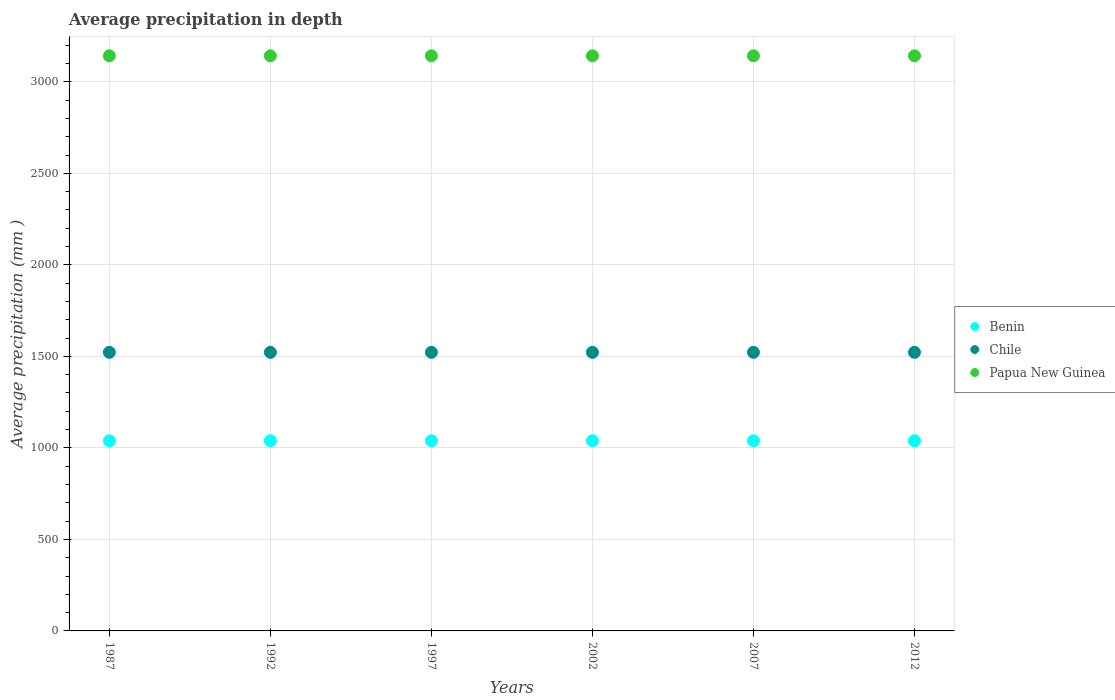What is the average precipitation in Papua New Guinea in 2002?
Give a very brief answer. 3142. Across all years, what is the maximum average precipitation in Benin?
Give a very brief answer. 1039. Across all years, what is the minimum average precipitation in Benin?
Ensure brevity in your answer.  1039. What is the total average precipitation in Chile in the graph?
Give a very brief answer. 9132. What is the difference between the average precipitation in Benin in 2002 and the average precipitation in Chile in 2007?
Your answer should be very brief. -483. What is the average average precipitation in Chile per year?
Your answer should be compact. 1522. In the year 1987, what is the difference between the average precipitation in Papua New Guinea and average precipitation in Benin?
Offer a terse response. 2103. Is the sum of the average precipitation in Papua New Guinea in 1992 and 2002 greater than the maximum average precipitation in Benin across all years?
Your response must be concise. Yes. Is it the case that in every year, the sum of the average precipitation in Benin and average precipitation in Chile  is greater than the average precipitation in Papua New Guinea?
Ensure brevity in your answer.  No. Does the average precipitation in Chile monotonically increase over the years?
Keep it short and to the point. No. Is the average precipitation in Papua New Guinea strictly greater than the average precipitation in Benin over the years?
Provide a succinct answer. Yes. How many dotlines are there?
Your response must be concise. 3. Does the graph contain grids?
Keep it short and to the point. Yes. How many legend labels are there?
Provide a short and direct response. 3. How are the legend labels stacked?
Provide a short and direct response. Vertical. What is the title of the graph?
Give a very brief answer. Average precipitation in depth. What is the label or title of the Y-axis?
Your response must be concise. Average precipitation (mm ). What is the Average precipitation (mm ) in Benin in 1987?
Offer a terse response. 1039. What is the Average precipitation (mm ) in Chile in 1987?
Provide a succinct answer. 1522. What is the Average precipitation (mm ) in Papua New Guinea in 1987?
Your response must be concise. 3142. What is the Average precipitation (mm ) of Benin in 1992?
Offer a terse response. 1039. What is the Average precipitation (mm ) in Chile in 1992?
Ensure brevity in your answer.  1522. What is the Average precipitation (mm ) in Papua New Guinea in 1992?
Offer a terse response. 3142. What is the Average precipitation (mm ) of Benin in 1997?
Ensure brevity in your answer.  1039. What is the Average precipitation (mm ) in Chile in 1997?
Make the answer very short. 1522. What is the Average precipitation (mm ) in Papua New Guinea in 1997?
Provide a succinct answer. 3142. What is the Average precipitation (mm ) in Benin in 2002?
Make the answer very short. 1039. What is the Average precipitation (mm ) of Chile in 2002?
Give a very brief answer. 1522. What is the Average precipitation (mm ) in Papua New Guinea in 2002?
Give a very brief answer. 3142. What is the Average precipitation (mm ) of Benin in 2007?
Your response must be concise. 1039. What is the Average precipitation (mm ) in Chile in 2007?
Provide a succinct answer. 1522. What is the Average precipitation (mm ) in Papua New Guinea in 2007?
Ensure brevity in your answer.  3142. What is the Average precipitation (mm ) in Benin in 2012?
Your answer should be very brief. 1039. What is the Average precipitation (mm ) of Chile in 2012?
Offer a terse response. 1522. What is the Average precipitation (mm ) of Papua New Guinea in 2012?
Provide a short and direct response. 3142. Across all years, what is the maximum Average precipitation (mm ) of Benin?
Ensure brevity in your answer.  1039. Across all years, what is the maximum Average precipitation (mm ) of Chile?
Ensure brevity in your answer.  1522. Across all years, what is the maximum Average precipitation (mm ) of Papua New Guinea?
Your answer should be very brief. 3142. Across all years, what is the minimum Average precipitation (mm ) in Benin?
Keep it short and to the point. 1039. Across all years, what is the minimum Average precipitation (mm ) in Chile?
Your answer should be compact. 1522. Across all years, what is the minimum Average precipitation (mm ) in Papua New Guinea?
Provide a short and direct response. 3142. What is the total Average precipitation (mm ) of Benin in the graph?
Your answer should be very brief. 6234. What is the total Average precipitation (mm ) in Chile in the graph?
Your answer should be compact. 9132. What is the total Average precipitation (mm ) of Papua New Guinea in the graph?
Give a very brief answer. 1.89e+04. What is the difference between the Average precipitation (mm ) in Benin in 1987 and that in 1992?
Provide a succinct answer. 0. What is the difference between the Average precipitation (mm ) in Papua New Guinea in 1987 and that in 1992?
Your response must be concise. 0. What is the difference between the Average precipitation (mm ) in Chile in 1987 and that in 1997?
Your answer should be compact. 0. What is the difference between the Average precipitation (mm ) in Papua New Guinea in 1987 and that in 1997?
Offer a very short reply. 0. What is the difference between the Average precipitation (mm ) in Chile in 1987 and that in 2002?
Provide a short and direct response. 0. What is the difference between the Average precipitation (mm ) of Papua New Guinea in 1987 and that in 2002?
Keep it short and to the point. 0. What is the difference between the Average precipitation (mm ) of Benin in 1987 and that in 2007?
Offer a very short reply. 0. What is the difference between the Average precipitation (mm ) of Chile in 1987 and that in 2007?
Offer a terse response. 0. What is the difference between the Average precipitation (mm ) of Papua New Guinea in 1987 and that in 2007?
Your response must be concise. 0. What is the difference between the Average precipitation (mm ) of Chile in 1987 and that in 2012?
Give a very brief answer. 0. What is the difference between the Average precipitation (mm ) of Papua New Guinea in 1987 and that in 2012?
Keep it short and to the point. 0. What is the difference between the Average precipitation (mm ) in Papua New Guinea in 1992 and that in 1997?
Your answer should be very brief. 0. What is the difference between the Average precipitation (mm ) of Benin in 1992 and that in 2002?
Offer a terse response. 0. What is the difference between the Average precipitation (mm ) in Chile in 1992 and that in 2002?
Keep it short and to the point. 0. What is the difference between the Average precipitation (mm ) in Papua New Guinea in 1992 and that in 2002?
Make the answer very short. 0. What is the difference between the Average precipitation (mm ) in Chile in 1992 and that in 2012?
Your answer should be very brief. 0. What is the difference between the Average precipitation (mm ) in Papua New Guinea in 1997 and that in 2002?
Your answer should be compact. 0. What is the difference between the Average precipitation (mm ) of Benin in 1997 and that in 2007?
Make the answer very short. 0. What is the difference between the Average precipitation (mm ) in Papua New Guinea in 1997 and that in 2012?
Offer a terse response. 0. What is the difference between the Average precipitation (mm ) in Benin in 2002 and that in 2007?
Keep it short and to the point. 0. What is the difference between the Average precipitation (mm ) in Chile in 2002 and that in 2007?
Give a very brief answer. 0. What is the difference between the Average precipitation (mm ) of Chile in 2002 and that in 2012?
Your response must be concise. 0. What is the difference between the Average precipitation (mm ) in Chile in 2007 and that in 2012?
Provide a short and direct response. 0. What is the difference between the Average precipitation (mm ) of Benin in 1987 and the Average precipitation (mm ) of Chile in 1992?
Offer a terse response. -483. What is the difference between the Average precipitation (mm ) of Benin in 1987 and the Average precipitation (mm ) of Papua New Guinea in 1992?
Keep it short and to the point. -2103. What is the difference between the Average precipitation (mm ) in Chile in 1987 and the Average precipitation (mm ) in Papua New Guinea in 1992?
Your answer should be very brief. -1620. What is the difference between the Average precipitation (mm ) in Benin in 1987 and the Average precipitation (mm ) in Chile in 1997?
Provide a short and direct response. -483. What is the difference between the Average precipitation (mm ) of Benin in 1987 and the Average precipitation (mm ) of Papua New Guinea in 1997?
Provide a short and direct response. -2103. What is the difference between the Average precipitation (mm ) of Chile in 1987 and the Average precipitation (mm ) of Papua New Guinea in 1997?
Your answer should be very brief. -1620. What is the difference between the Average precipitation (mm ) in Benin in 1987 and the Average precipitation (mm ) in Chile in 2002?
Offer a terse response. -483. What is the difference between the Average precipitation (mm ) in Benin in 1987 and the Average precipitation (mm ) in Papua New Guinea in 2002?
Offer a terse response. -2103. What is the difference between the Average precipitation (mm ) in Chile in 1987 and the Average precipitation (mm ) in Papua New Guinea in 2002?
Your response must be concise. -1620. What is the difference between the Average precipitation (mm ) in Benin in 1987 and the Average precipitation (mm ) in Chile in 2007?
Offer a terse response. -483. What is the difference between the Average precipitation (mm ) in Benin in 1987 and the Average precipitation (mm ) in Papua New Guinea in 2007?
Your answer should be compact. -2103. What is the difference between the Average precipitation (mm ) of Chile in 1987 and the Average precipitation (mm ) of Papua New Guinea in 2007?
Your response must be concise. -1620. What is the difference between the Average precipitation (mm ) in Benin in 1987 and the Average precipitation (mm ) in Chile in 2012?
Give a very brief answer. -483. What is the difference between the Average precipitation (mm ) in Benin in 1987 and the Average precipitation (mm ) in Papua New Guinea in 2012?
Keep it short and to the point. -2103. What is the difference between the Average precipitation (mm ) in Chile in 1987 and the Average precipitation (mm ) in Papua New Guinea in 2012?
Keep it short and to the point. -1620. What is the difference between the Average precipitation (mm ) in Benin in 1992 and the Average precipitation (mm ) in Chile in 1997?
Provide a short and direct response. -483. What is the difference between the Average precipitation (mm ) of Benin in 1992 and the Average precipitation (mm ) of Papua New Guinea in 1997?
Provide a short and direct response. -2103. What is the difference between the Average precipitation (mm ) in Chile in 1992 and the Average precipitation (mm ) in Papua New Guinea in 1997?
Your answer should be compact. -1620. What is the difference between the Average precipitation (mm ) of Benin in 1992 and the Average precipitation (mm ) of Chile in 2002?
Your answer should be very brief. -483. What is the difference between the Average precipitation (mm ) in Benin in 1992 and the Average precipitation (mm ) in Papua New Guinea in 2002?
Your response must be concise. -2103. What is the difference between the Average precipitation (mm ) of Chile in 1992 and the Average precipitation (mm ) of Papua New Guinea in 2002?
Ensure brevity in your answer.  -1620. What is the difference between the Average precipitation (mm ) in Benin in 1992 and the Average precipitation (mm ) in Chile in 2007?
Your answer should be very brief. -483. What is the difference between the Average precipitation (mm ) of Benin in 1992 and the Average precipitation (mm ) of Papua New Guinea in 2007?
Provide a short and direct response. -2103. What is the difference between the Average precipitation (mm ) in Chile in 1992 and the Average precipitation (mm ) in Papua New Guinea in 2007?
Ensure brevity in your answer.  -1620. What is the difference between the Average precipitation (mm ) in Benin in 1992 and the Average precipitation (mm ) in Chile in 2012?
Offer a terse response. -483. What is the difference between the Average precipitation (mm ) of Benin in 1992 and the Average precipitation (mm ) of Papua New Guinea in 2012?
Ensure brevity in your answer.  -2103. What is the difference between the Average precipitation (mm ) in Chile in 1992 and the Average precipitation (mm ) in Papua New Guinea in 2012?
Make the answer very short. -1620. What is the difference between the Average precipitation (mm ) in Benin in 1997 and the Average precipitation (mm ) in Chile in 2002?
Provide a short and direct response. -483. What is the difference between the Average precipitation (mm ) of Benin in 1997 and the Average precipitation (mm ) of Papua New Guinea in 2002?
Your answer should be very brief. -2103. What is the difference between the Average precipitation (mm ) in Chile in 1997 and the Average precipitation (mm ) in Papua New Guinea in 2002?
Ensure brevity in your answer.  -1620. What is the difference between the Average precipitation (mm ) of Benin in 1997 and the Average precipitation (mm ) of Chile in 2007?
Provide a succinct answer. -483. What is the difference between the Average precipitation (mm ) of Benin in 1997 and the Average precipitation (mm ) of Papua New Guinea in 2007?
Ensure brevity in your answer.  -2103. What is the difference between the Average precipitation (mm ) of Chile in 1997 and the Average precipitation (mm ) of Papua New Guinea in 2007?
Give a very brief answer. -1620. What is the difference between the Average precipitation (mm ) of Benin in 1997 and the Average precipitation (mm ) of Chile in 2012?
Offer a terse response. -483. What is the difference between the Average precipitation (mm ) in Benin in 1997 and the Average precipitation (mm ) in Papua New Guinea in 2012?
Your response must be concise. -2103. What is the difference between the Average precipitation (mm ) of Chile in 1997 and the Average precipitation (mm ) of Papua New Guinea in 2012?
Your response must be concise. -1620. What is the difference between the Average precipitation (mm ) in Benin in 2002 and the Average precipitation (mm ) in Chile in 2007?
Offer a terse response. -483. What is the difference between the Average precipitation (mm ) of Benin in 2002 and the Average precipitation (mm ) of Papua New Guinea in 2007?
Your answer should be compact. -2103. What is the difference between the Average precipitation (mm ) in Chile in 2002 and the Average precipitation (mm ) in Papua New Guinea in 2007?
Make the answer very short. -1620. What is the difference between the Average precipitation (mm ) in Benin in 2002 and the Average precipitation (mm ) in Chile in 2012?
Your answer should be compact. -483. What is the difference between the Average precipitation (mm ) in Benin in 2002 and the Average precipitation (mm ) in Papua New Guinea in 2012?
Provide a short and direct response. -2103. What is the difference between the Average precipitation (mm ) in Chile in 2002 and the Average precipitation (mm ) in Papua New Guinea in 2012?
Keep it short and to the point. -1620. What is the difference between the Average precipitation (mm ) in Benin in 2007 and the Average precipitation (mm ) in Chile in 2012?
Make the answer very short. -483. What is the difference between the Average precipitation (mm ) in Benin in 2007 and the Average precipitation (mm ) in Papua New Guinea in 2012?
Offer a terse response. -2103. What is the difference between the Average precipitation (mm ) of Chile in 2007 and the Average precipitation (mm ) of Papua New Guinea in 2012?
Make the answer very short. -1620. What is the average Average precipitation (mm ) in Benin per year?
Provide a succinct answer. 1039. What is the average Average precipitation (mm ) in Chile per year?
Make the answer very short. 1522. What is the average Average precipitation (mm ) in Papua New Guinea per year?
Provide a succinct answer. 3142. In the year 1987, what is the difference between the Average precipitation (mm ) in Benin and Average precipitation (mm ) in Chile?
Give a very brief answer. -483. In the year 1987, what is the difference between the Average precipitation (mm ) in Benin and Average precipitation (mm ) in Papua New Guinea?
Keep it short and to the point. -2103. In the year 1987, what is the difference between the Average precipitation (mm ) in Chile and Average precipitation (mm ) in Papua New Guinea?
Provide a short and direct response. -1620. In the year 1992, what is the difference between the Average precipitation (mm ) of Benin and Average precipitation (mm ) of Chile?
Provide a succinct answer. -483. In the year 1992, what is the difference between the Average precipitation (mm ) in Benin and Average precipitation (mm ) in Papua New Guinea?
Your answer should be compact. -2103. In the year 1992, what is the difference between the Average precipitation (mm ) in Chile and Average precipitation (mm ) in Papua New Guinea?
Your answer should be very brief. -1620. In the year 1997, what is the difference between the Average precipitation (mm ) in Benin and Average precipitation (mm ) in Chile?
Offer a terse response. -483. In the year 1997, what is the difference between the Average precipitation (mm ) of Benin and Average precipitation (mm ) of Papua New Guinea?
Your answer should be very brief. -2103. In the year 1997, what is the difference between the Average precipitation (mm ) of Chile and Average precipitation (mm ) of Papua New Guinea?
Make the answer very short. -1620. In the year 2002, what is the difference between the Average precipitation (mm ) of Benin and Average precipitation (mm ) of Chile?
Your answer should be very brief. -483. In the year 2002, what is the difference between the Average precipitation (mm ) in Benin and Average precipitation (mm ) in Papua New Guinea?
Your answer should be compact. -2103. In the year 2002, what is the difference between the Average precipitation (mm ) of Chile and Average precipitation (mm ) of Papua New Guinea?
Provide a short and direct response. -1620. In the year 2007, what is the difference between the Average precipitation (mm ) of Benin and Average precipitation (mm ) of Chile?
Give a very brief answer. -483. In the year 2007, what is the difference between the Average precipitation (mm ) of Benin and Average precipitation (mm ) of Papua New Guinea?
Make the answer very short. -2103. In the year 2007, what is the difference between the Average precipitation (mm ) in Chile and Average precipitation (mm ) in Papua New Guinea?
Give a very brief answer. -1620. In the year 2012, what is the difference between the Average precipitation (mm ) in Benin and Average precipitation (mm ) in Chile?
Provide a short and direct response. -483. In the year 2012, what is the difference between the Average precipitation (mm ) of Benin and Average precipitation (mm ) of Papua New Guinea?
Offer a terse response. -2103. In the year 2012, what is the difference between the Average precipitation (mm ) in Chile and Average precipitation (mm ) in Papua New Guinea?
Ensure brevity in your answer.  -1620. What is the ratio of the Average precipitation (mm ) in Benin in 1987 to that in 1992?
Your answer should be very brief. 1. What is the ratio of the Average precipitation (mm ) of Benin in 1987 to that in 1997?
Make the answer very short. 1. What is the ratio of the Average precipitation (mm ) of Papua New Guinea in 1987 to that in 1997?
Offer a terse response. 1. What is the ratio of the Average precipitation (mm ) of Benin in 1987 to that in 2002?
Provide a short and direct response. 1. What is the ratio of the Average precipitation (mm ) in Chile in 1987 to that in 2007?
Make the answer very short. 1. What is the ratio of the Average precipitation (mm ) of Papua New Guinea in 1987 to that in 2007?
Give a very brief answer. 1. What is the ratio of the Average precipitation (mm ) of Benin in 1987 to that in 2012?
Provide a short and direct response. 1. What is the ratio of the Average precipitation (mm ) of Benin in 1992 to that in 1997?
Your answer should be very brief. 1. What is the ratio of the Average precipitation (mm ) of Chile in 1992 to that in 1997?
Your response must be concise. 1. What is the ratio of the Average precipitation (mm ) of Papua New Guinea in 1992 to that in 1997?
Your answer should be compact. 1. What is the ratio of the Average precipitation (mm ) of Benin in 1992 to that in 2002?
Your response must be concise. 1. What is the ratio of the Average precipitation (mm ) in Chile in 1992 to that in 2002?
Provide a short and direct response. 1. What is the ratio of the Average precipitation (mm ) of Papua New Guinea in 1992 to that in 2002?
Your response must be concise. 1. What is the ratio of the Average precipitation (mm ) in Benin in 1992 to that in 2007?
Provide a succinct answer. 1. What is the ratio of the Average precipitation (mm ) of Chile in 1992 to that in 2007?
Offer a terse response. 1. What is the ratio of the Average precipitation (mm ) of Chile in 1992 to that in 2012?
Make the answer very short. 1. What is the ratio of the Average precipitation (mm ) in Papua New Guinea in 1992 to that in 2012?
Keep it short and to the point. 1. What is the ratio of the Average precipitation (mm ) in Benin in 1997 to that in 2002?
Provide a short and direct response. 1. What is the ratio of the Average precipitation (mm ) of Chile in 1997 to that in 2002?
Make the answer very short. 1. What is the ratio of the Average precipitation (mm ) of Papua New Guinea in 1997 to that in 2002?
Make the answer very short. 1. What is the ratio of the Average precipitation (mm ) in Benin in 1997 to that in 2007?
Provide a short and direct response. 1. What is the ratio of the Average precipitation (mm ) of Chile in 2002 to that in 2012?
Provide a short and direct response. 1. What is the ratio of the Average precipitation (mm ) in Benin in 2007 to that in 2012?
Offer a terse response. 1. What is the ratio of the Average precipitation (mm ) of Chile in 2007 to that in 2012?
Ensure brevity in your answer.  1. What is the difference between the highest and the lowest Average precipitation (mm ) in Chile?
Provide a succinct answer. 0. 